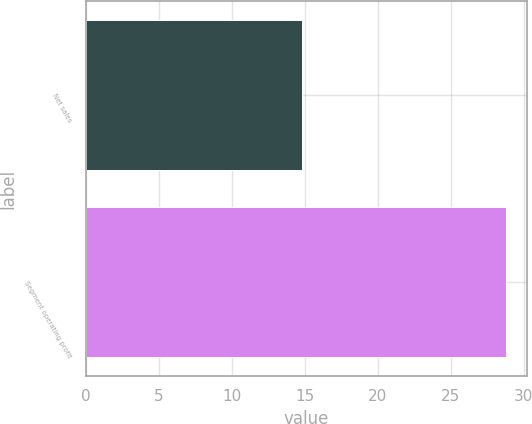Convert chart. <chart><loc_0><loc_0><loc_500><loc_500><bar_chart><fcel>Net sales<fcel>Segment operating profit<nl><fcel>14.8<fcel>28.8<nl></chart> 